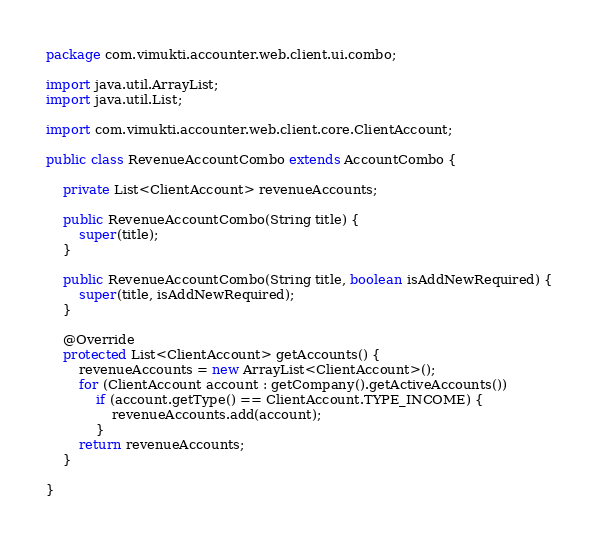Convert code to text. <code><loc_0><loc_0><loc_500><loc_500><_Java_>package com.vimukti.accounter.web.client.ui.combo;

import java.util.ArrayList;
import java.util.List;

import com.vimukti.accounter.web.client.core.ClientAccount;

public class RevenueAccountCombo extends AccountCombo {

	private List<ClientAccount> revenueAccounts;

	public RevenueAccountCombo(String title) {
		super(title);
	}

	public RevenueAccountCombo(String title, boolean isAddNewRequired) {
		super(title, isAddNewRequired);
	}

	@Override
	protected List<ClientAccount> getAccounts() {
		revenueAccounts = new ArrayList<ClientAccount>();
		for (ClientAccount account : getCompany().getActiveAccounts())
			if (account.getType() == ClientAccount.TYPE_INCOME) {
				revenueAccounts.add(account);
			}
		return revenueAccounts;
	}

}
</code> 